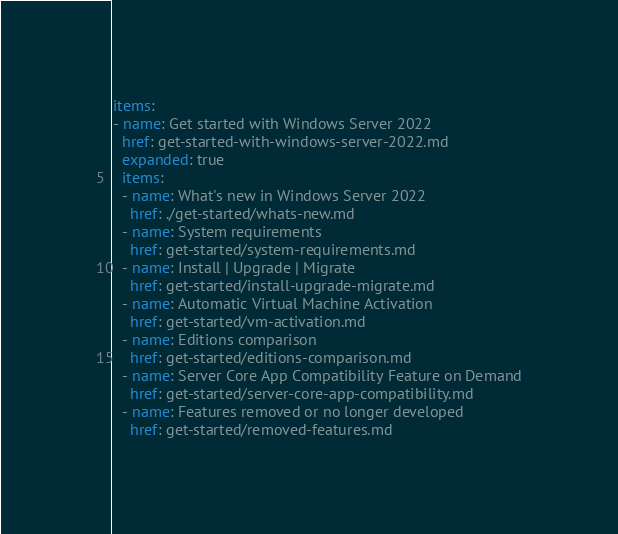Convert code to text. <code><loc_0><loc_0><loc_500><loc_500><_YAML_>items:
- name: Get started with Windows Server 2022
  href: get-started-with-windows-server-2022.md
  expanded: true
  items:
  - name: What's new in Windows Server 2022
    href: ./get-started/whats-new.md
  - name: System requirements
    href: get-started/system-requirements.md
  - name: Install | Upgrade | Migrate
    href: get-started/install-upgrade-migrate.md
  - name: Automatic Virtual Machine Activation
    href: get-started/vm-activation.md
  - name: Editions comparison
    href: get-started/editions-comparison.md
  - name: Server Core App Compatibility Feature on Demand
    href: get-started/server-core-app-compatibility.md
  - name: Features removed or no longer developed
    href: get-started/removed-features.md
</code> 